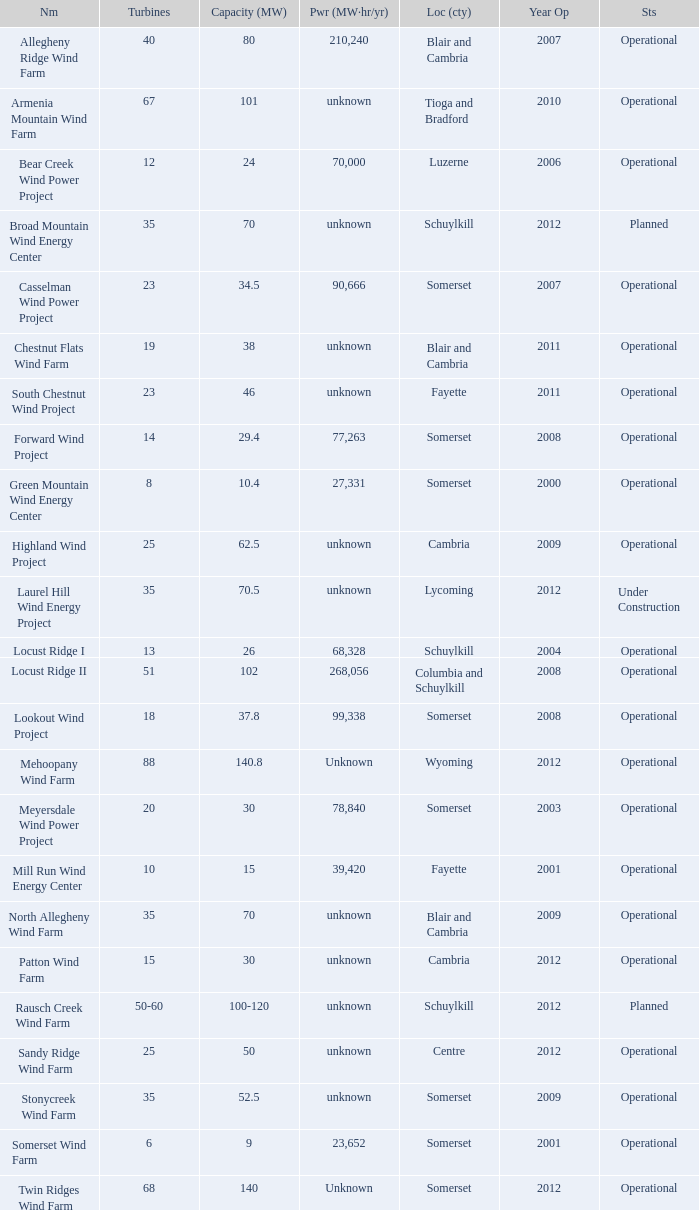What locations are considered centre? Unknown. 